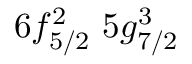Convert formula to latex. <formula><loc_0><loc_0><loc_500><loc_500>6 f _ { 5 / 2 } ^ { 2 } \, 5 g _ { 7 / 2 } ^ { 3 }</formula> 